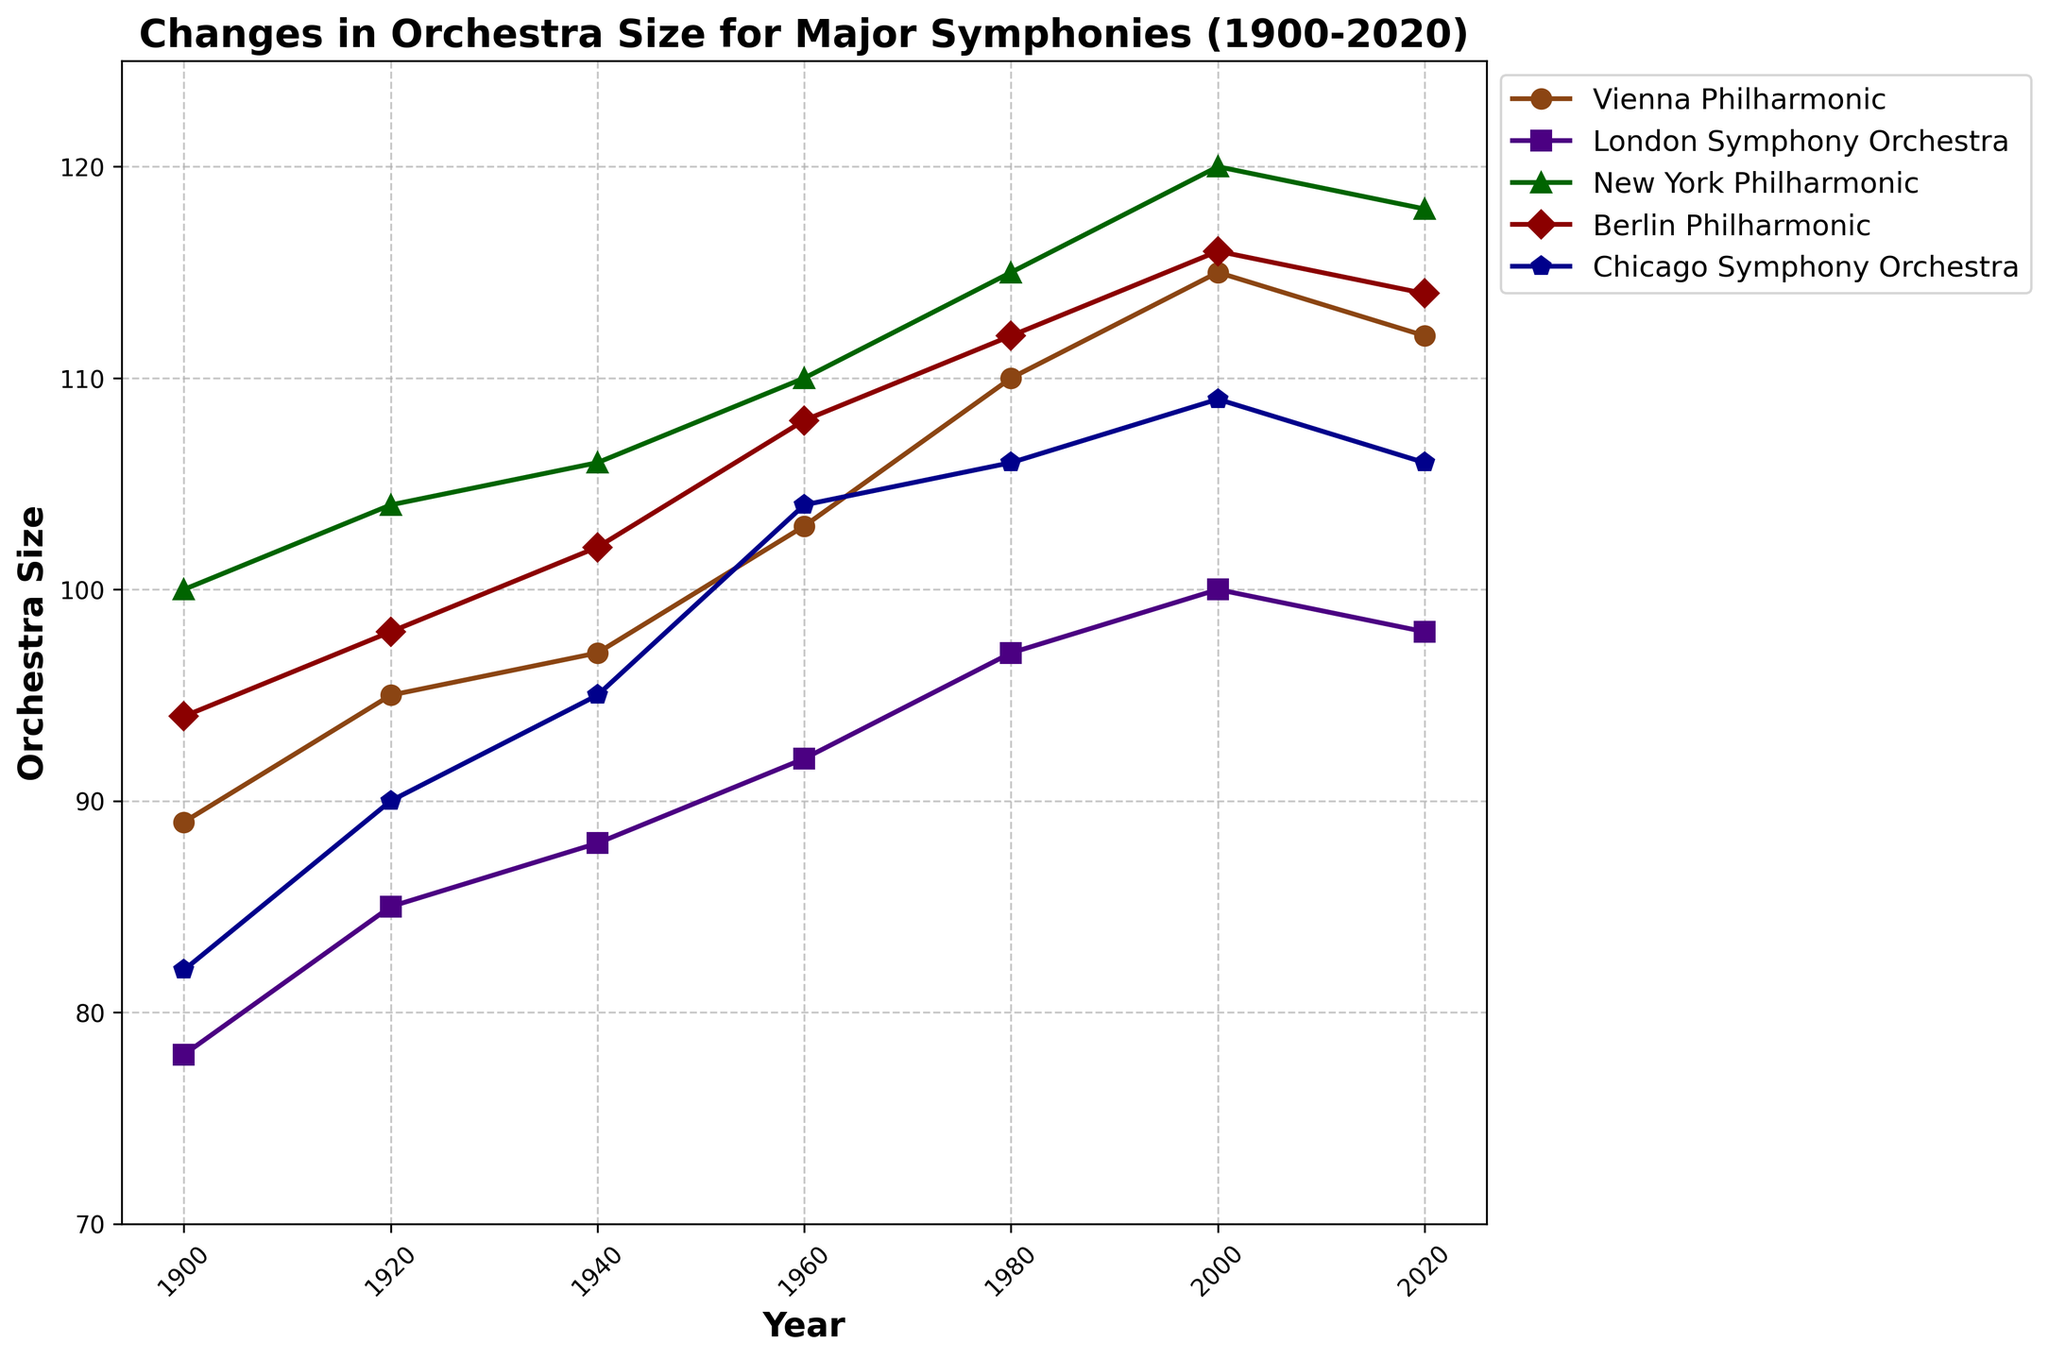What's the approximate average size of the Vienna Philharmonic from 1900 to 2020? Add the sizes from all years (89 + 95 + 97 + 103 + 110 + 115 + 112) and then divide by the number of data points (7). The total is 721, so the average is 721/7 = 103.
Answer: 103 Which orchestra had the smallest size in 1920? Look at the data points for the year 1920. The London Symphony Orchestra has the smallest size at 85.
Answer: London Symphony Orchestra Between which consecutive 20 years did the Berlin Philharmonic experience the largest increase? Calculate the differences for each 20-year interval: from 1900 to 1920 (+4), from 1920 to 1940 (+4), from 1940 to 1960 (+6), from 1960 to 1980 (+4), from 1980 to 2000 (+4), and from 2000 to 2020 (-2). The largest increase is between 1940 and 1960 (+6).
Answer: 1940 to 1960 From 1900 to 2020, which orchestra showed the least variation in size? Look at the range (maximum value - minimum value) for each orchestra. The London Symphony Orchestra varies from 78 to 100, giving a range of 22, which is the smallest of all the orchestras shown.
Answer: London Symphony Orchestra What is the difference in the size of the New York Philharmonic between 1900 and 2020? Subtract the size in 1900 (100) from the size in 2020 (118). The difference is 118 - 100 = 18.
Answer: 18 Which orchestra reached its peak size latest in the timeline? The Vienna Philharmonic peaked at 115 in 2000. The London Symphony Orchestra's peak was 100 in 2000. The New York Philharmonic's peak was 120 in 2000. The Berlin Philharmonic's peak was 116 in 2000. The Chicago Symphony Orchestra's peak was 109 in 2000. All these peaks were in 2000, so no orchestra reached its peak latest.
Answer: None What is the total orchestra size for the Berlin Philharmonic and Chicago Symphony Orchestra in 2020? Add the sizes of Berlin Philharmonic (114) and Chicago Symphony Orchestra (106) in 2020. The total is 114 + 106 = 220.
Answer: 220 What general trend do you observe in orchestra sizes over the years? Most orchestras show an increase in size from 1900 to 2000, followed by a slight decline or stabilization from 2000 to 2020.
Answer: Increase then stabilize/decline By how much did the Chicago Symphony Orchestra grow from 1900 to 2000? Subtract the size in 1900 (82) from the size in 2000 (109). The growth is 109 - 82 = 27.
Answer: 27 